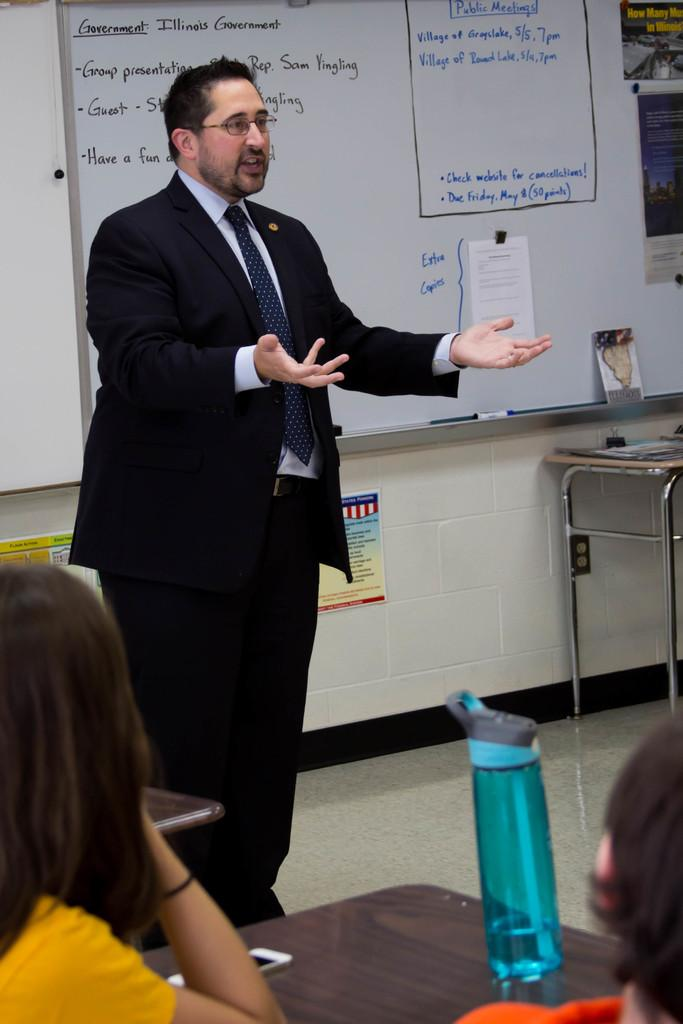What is the man in the image doing? The man is standing and speaking in the image. What are the people in the image doing? The people are seated in the image. What objects can be seen on the table in the image? There is a water bottle and a mobile on the table in the image. What is the purpose of the whiteboard visible in the image? The whiteboard is likely used for writing or displaying information. What type of credit card is the man using in the image? There is no credit card visible in the image; the man is speaking and standing. Is there any evidence of a crime being committed in the image? There is no indication of a crime being committed in the image. 